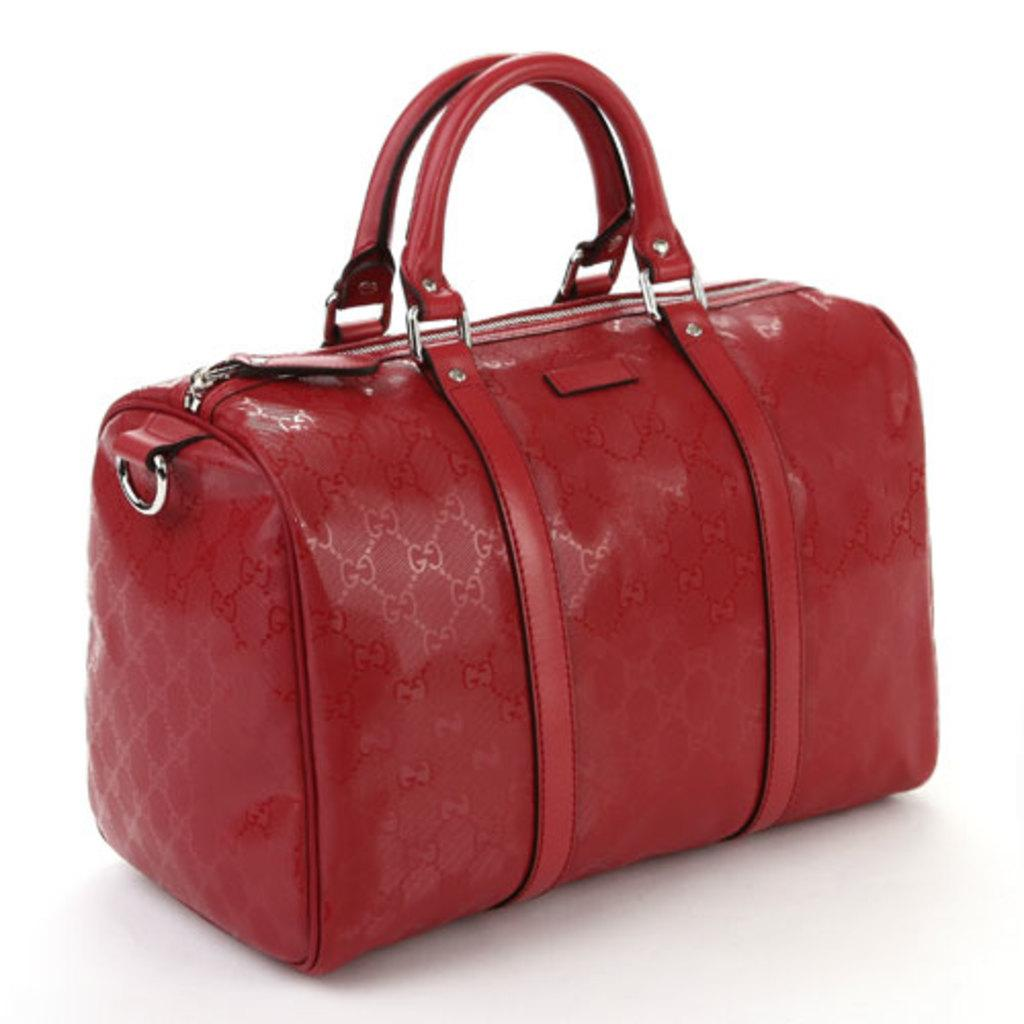What is the color of the bag in the image? The bag is red in color. What type of closure does the bag have? The bag has a silver zipper. How can the bag be carried? The bag has two red-colored handles for carrying. How many cats are sitting on the bag in the image? There are no cats present in the image. What type of twist can be seen on the bag? There is no twist on the bag in the image; it has a silver zipper for closure. 